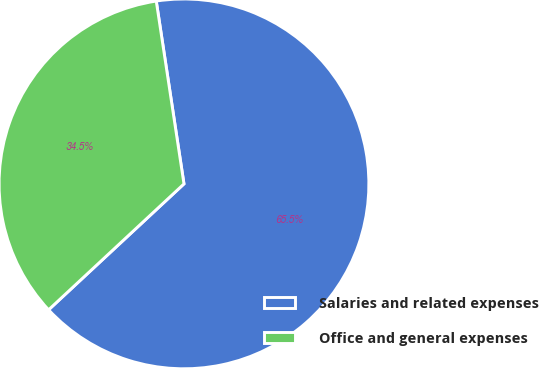Convert chart. <chart><loc_0><loc_0><loc_500><loc_500><pie_chart><fcel>Salaries and related expenses<fcel>Office and general expenses<nl><fcel>65.47%<fcel>34.53%<nl></chart> 